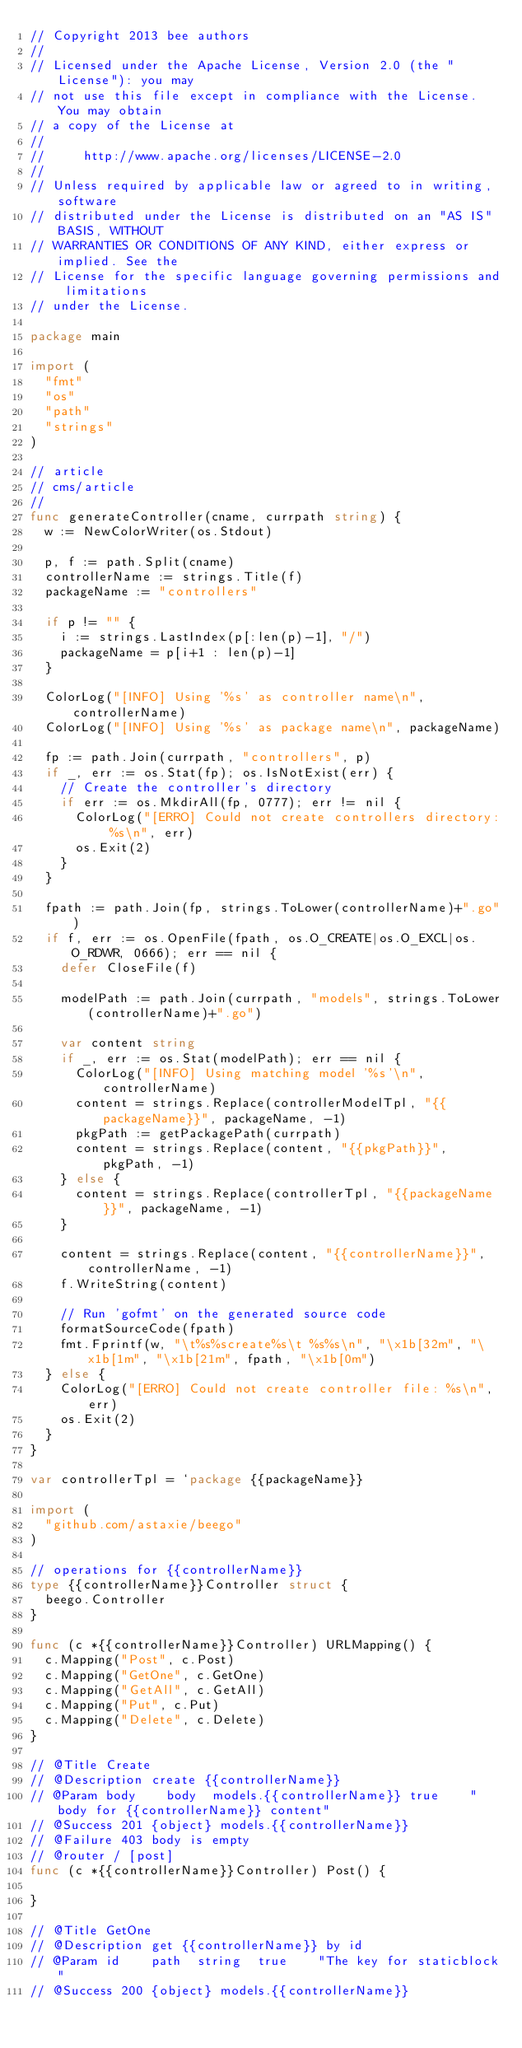Convert code to text. <code><loc_0><loc_0><loc_500><loc_500><_Go_>// Copyright 2013 bee authors
//
// Licensed under the Apache License, Version 2.0 (the "License"): you may
// not use this file except in compliance with the License. You may obtain
// a copy of the License at
//
//     http://www.apache.org/licenses/LICENSE-2.0
//
// Unless required by applicable law or agreed to in writing, software
// distributed under the License is distributed on an "AS IS" BASIS, WITHOUT
// WARRANTIES OR CONDITIONS OF ANY KIND, either express or implied. See the
// License for the specific language governing permissions and limitations
// under the License.

package main

import (
	"fmt"
	"os"
	"path"
	"strings"
)

// article
// cms/article
//
func generateController(cname, currpath string) {
	w := NewColorWriter(os.Stdout)

	p, f := path.Split(cname)
	controllerName := strings.Title(f)
	packageName := "controllers"

	if p != "" {
		i := strings.LastIndex(p[:len(p)-1], "/")
		packageName = p[i+1 : len(p)-1]
	}

	ColorLog("[INFO] Using '%s' as controller name\n", controllerName)
	ColorLog("[INFO] Using '%s' as package name\n", packageName)

	fp := path.Join(currpath, "controllers", p)
	if _, err := os.Stat(fp); os.IsNotExist(err) {
		// Create the controller's directory
		if err := os.MkdirAll(fp, 0777); err != nil {
			ColorLog("[ERRO] Could not create controllers directory: %s\n", err)
			os.Exit(2)
		}
	}

	fpath := path.Join(fp, strings.ToLower(controllerName)+".go")
	if f, err := os.OpenFile(fpath, os.O_CREATE|os.O_EXCL|os.O_RDWR, 0666); err == nil {
		defer CloseFile(f)

		modelPath := path.Join(currpath, "models", strings.ToLower(controllerName)+".go")

		var content string
		if _, err := os.Stat(modelPath); err == nil {
			ColorLog("[INFO] Using matching model '%s'\n", controllerName)
			content = strings.Replace(controllerModelTpl, "{{packageName}}", packageName, -1)
			pkgPath := getPackagePath(currpath)
			content = strings.Replace(content, "{{pkgPath}}", pkgPath, -1)
		} else {
			content = strings.Replace(controllerTpl, "{{packageName}}", packageName, -1)
		}

		content = strings.Replace(content, "{{controllerName}}", controllerName, -1)
		f.WriteString(content)

		// Run 'gofmt' on the generated source code
		formatSourceCode(fpath)
		fmt.Fprintf(w, "\t%s%screate%s\t %s%s\n", "\x1b[32m", "\x1b[1m", "\x1b[21m", fpath, "\x1b[0m")
	} else {
		ColorLog("[ERRO] Could not create controller file: %s\n", err)
		os.Exit(2)
	}
}

var controllerTpl = `package {{packageName}}

import (
	"github.com/astaxie/beego"
)

// operations for {{controllerName}}
type {{controllerName}}Controller struct {
	beego.Controller
}

func (c *{{controllerName}}Controller) URLMapping() {
	c.Mapping("Post", c.Post)
	c.Mapping("GetOne", c.GetOne)
	c.Mapping("GetAll", c.GetAll)
	c.Mapping("Put", c.Put)
	c.Mapping("Delete", c.Delete)
}

// @Title Create
// @Description create {{controllerName}}
// @Param	body		body 	models.{{controllerName}}	true		"body for {{controllerName}} content"
// @Success 201 {object} models.{{controllerName}}
// @Failure 403 body is empty
// @router / [post]
func (c *{{controllerName}}Controller) Post() {

}

// @Title GetOne
// @Description get {{controllerName}} by id
// @Param	id		path 	string	true		"The key for staticblock"
// @Success 200 {object} models.{{controllerName}}</code> 